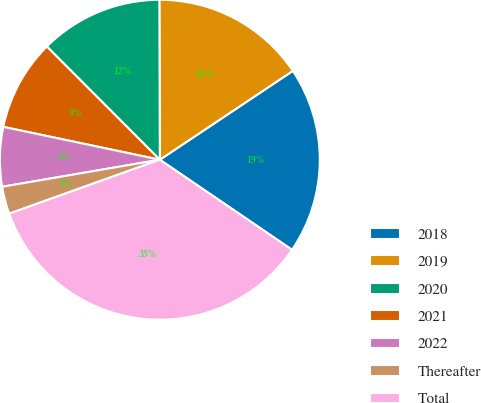Convert chart to OTSL. <chart><loc_0><loc_0><loc_500><loc_500><pie_chart><fcel>2018<fcel>2019<fcel>2020<fcel>2021<fcel>2022<fcel>Thereafter<fcel>Total<nl><fcel>18.89%<fcel>15.67%<fcel>12.44%<fcel>9.22%<fcel>6.0%<fcel>2.77%<fcel>35.01%<nl></chart> 